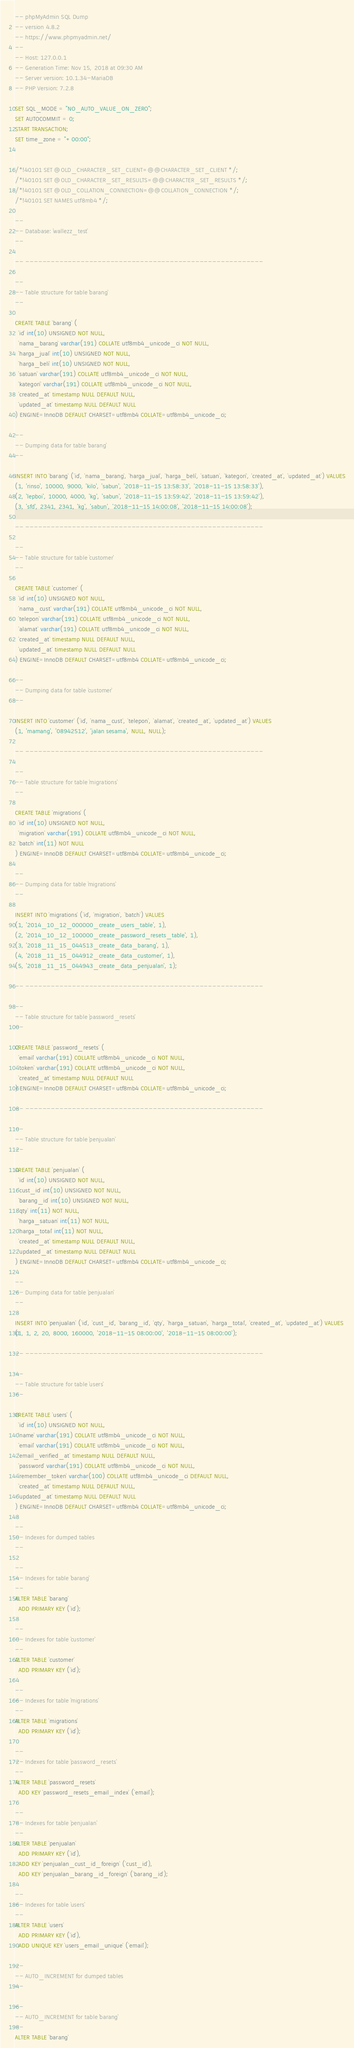Convert code to text. <code><loc_0><loc_0><loc_500><loc_500><_SQL_>-- phpMyAdmin SQL Dump
-- version 4.8.2
-- https://www.phpmyadmin.net/
--
-- Host: 127.0.0.1
-- Generation Time: Nov 15, 2018 at 09:30 AM
-- Server version: 10.1.34-MariaDB
-- PHP Version: 7.2.8

SET SQL_MODE = "NO_AUTO_VALUE_ON_ZERO";
SET AUTOCOMMIT = 0;
START TRANSACTION;
SET time_zone = "+00:00";


/*!40101 SET @OLD_CHARACTER_SET_CLIENT=@@CHARACTER_SET_CLIENT */;
/*!40101 SET @OLD_CHARACTER_SET_RESULTS=@@CHARACTER_SET_RESULTS */;
/*!40101 SET @OLD_COLLATION_CONNECTION=@@COLLATION_CONNECTION */;
/*!40101 SET NAMES utf8mb4 */;

--
-- Database: `wallezz_test`
--

-- --------------------------------------------------------

--
-- Table structure for table `barang`
--

CREATE TABLE `barang` (
  `id` int(10) UNSIGNED NOT NULL,
  `nama_barang` varchar(191) COLLATE utf8mb4_unicode_ci NOT NULL,
  `harga_jual` int(10) UNSIGNED NOT NULL,
  `harga_beli` int(10) UNSIGNED NOT NULL,
  `satuan` varchar(191) COLLATE utf8mb4_unicode_ci NOT NULL,
  `kategori` varchar(191) COLLATE utf8mb4_unicode_ci NOT NULL,
  `created_at` timestamp NULL DEFAULT NULL,
  `updated_at` timestamp NULL DEFAULT NULL
) ENGINE=InnoDB DEFAULT CHARSET=utf8mb4 COLLATE=utf8mb4_unicode_ci;

--
-- Dumping data for table `barang`
--

INSERT INTO `barang` (`id`, `nama_barang`, `harga_jual`, `harga_beli`, `satuan`, `kategori`, `created_at`, `updated_at`) VALUES
(1, 'rinso', 10000, 9000, 'kilo', 'sabun', '2018-11-15 13:58:33', '2018-11-15 13:58:33'),
(2, 'lepboi', 10000, 4000, 'kg', 'sabun', '2018-11-15 13:59:42', '2018-11-15 13:59:42'),
(3, 'sfd', 2341, 2341, 'kg', 'sabun', '2018-11-15 14:00:08', '2018-11-15 14:00:08');

-- --------------------------------------------------------

--
-- Table structure for table `customer`
--

CREATE TABLE `customer` (
  `id` int(10) UNSIGNED NOT NULL,
  `nama_cust` varchar(191) COLLATE utf8mb4_unicode_ci NOT NULL,
  `telepon` varchar(191) COLLATE utf8mb4_unicode_ci NOT NULL,
  `alamat` varchar(191) COLLATE utf8mb4_unicode_ci NOT NULL,
  `created_at` timestamp NULL DEFAULT NULL,
  `updated_at` timestamp NULL DEFAULT NULL
) ENGINE=InnoDB DEFAULT CHARSET=utf8mb4 COLLATE=utf8mb4_unicode_ci;

--
-- Dumping data for table `customer`
--

INSERT INTO `customer` (`id`, `nama_cust`, `telepon`, `alamat`, `created_at`, `updated_at`) VALUES
(1, 'mamang', '08942512', 'jalan sesama', NULL, NULL);

-- --------------------------------------------------------

--
-- Table structure for table `migrations`
--

CREATE TABLE `migrations` (
  `id` int(10) UNSIGNED NOT NULL,
  `migration` varchar(191) COLLATE utf8mb4_unicode_ci NOT NULL,
  `batch` int(11) NOT NULL
) ENGINE=InnoDB DEFAULT CHARSET=utf8mb4 COLLATE=utf8mb4_unicode_ci;

--
-- Dumping data for table `migrations`
--

INSERT INTO `migrations` (`id`, `migration`, `batch`) VALUES
(1, '2014_10_12_000000_create_users_table', 1),
(2, '2014_10_12_100000_create_password_resets_table', 1),
(3, '2018_11_15_044513_create_data_barang', 1),
(4, '2018_11_15_044912_create_data_customer', 1),
(5, '2018_11_15_044943_create_data_penjualan', 1);

-- --------------------------------------------------------

--
-- Table structure for table `password_resets`
--

CREATE TABLE `password_resets` (
  `email` varchar(191) COLLATE utf8mb4_unicode_ci NOT NULL,
  `token` varchar(191) COLLATE utf8mb4_unicode_ci NOT NULL,
  `created_at` timestamp NULL DEFAULT NULL
) ENGINE=InnoDB DEFAULT CHARSET=utf8mb4 COLLATE=utf8mb4_unicode_ci;

-- --------------------------------------------------------

--
-- Table structure for table `penjualan`
--

CREATE TABLE `penjualan` (
  `id` int(10) UNSIGNED NOT NULL,
  `cust_id` int(10) UNSIGNED NOT NULL,
  `barang_id` int(10) UNSIGNED NOT NULL,
  `qty` int(11) NOT NULL,
  `harga_satuan` int(11) NOT NULL,
  `harga_total` int(11) NOT NULL,
  `created_at` timestamp NULL DEFAULT NULL,
  `updated_at` timestamp NULL DEFAULT NULL
) ENGINE=InnoDB DEFAULT CHARSET=utf8mb4 COLLATE=utf8mb4_unicode_ci;

--
-- Dumping data for table `penjualan`
--

INSERT INTO `penjualan` (`id`, `cust_id`, `barang_id`, `qty`, `harga_satuan`, `harga_total`, `created_at`, `updated_at`) VALUES
(1, 1, 2, 20, 8000, 160000, '2018-11-15 08:00:00', '2018-11-15 08:00:00');

-- --------------------------------------------------------

--
-- Table structure for table `users`
--

CREATE TABLE `users` (
  `id` int(10) UNSIGNED NOT NULL,
  `name` varchar(191) COLLATE utf8mb4_unicode_ci NOT NULL,
  `email` varchar(191) COLLATE utf8mb4_unicode_ci NOT NULL,
  `email_verified_at` timestamp NULL DEFAULT NULL,
  `password` varchar(191) COLLATE utf8mb4_unicode_ci NOT NULL,
  `remember_token` varchar(100) COLLATE utf8mb4_unicode_ci DEFAULT NULL,
  `created_at` timestamp NULL DEFAULT NULL,
  `updated_at` timestamp NULL DEFAULT NULL
) ENGINE=InnoDB DEFAULT CHARSET=utf8mb4 COLLATE=utf8mb4_unicode_ci;

--
-- Indexes for dumped tables
--

--
-- Indexes for table `barang`
--
ALTER TABLE `barang`
  ADD PRIMARY KEY (`id`);

--
-- Indexes for table `customer`
--
ALTER TABLE `customer`
  ADD PRIMARY KEY (`id`);

--
-- Indexes for table `migrations`
--
ALTER TABLE `migrations`
  ADD PRIMARY KEY (`id`);

--
-- Indexes for table `password_resets`
--
ALTER TABLE `password_resets`
  ADD KEY `password_resets_email_index` (`email`);

--
-- Indexes for table `penjualan`
--
ALTER TABLE `penjualan`
  ADD PRIMARY KEY (`id`),
  ADD KEY `penjualan_cust_id_foreign` (`cust_id`),
  ADD KEY `penjualan_barang_id_foreign` (`barang_id`);

--
-- Indexes for table `users`
--
ALTER TABLE `users`
  ADD PRIMARY KEY (`id`),
  ADD UNIQUE KEY `users_email_unique` (`email`);

--
-- AUTO_INCREMENT for dumped tables
--

--
-- AUTO_INCREMENT for table `barang`
--
ALTER TABLE `barang`</code> 